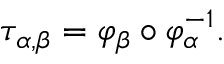<formula> <loc_0><loc_0><loc_500><loc_500>\tau _ { \alpha , \beta } = \varphi _ { \beta } \circ \varphi _ { \alpha } ^ { - 1 } .</formula> 